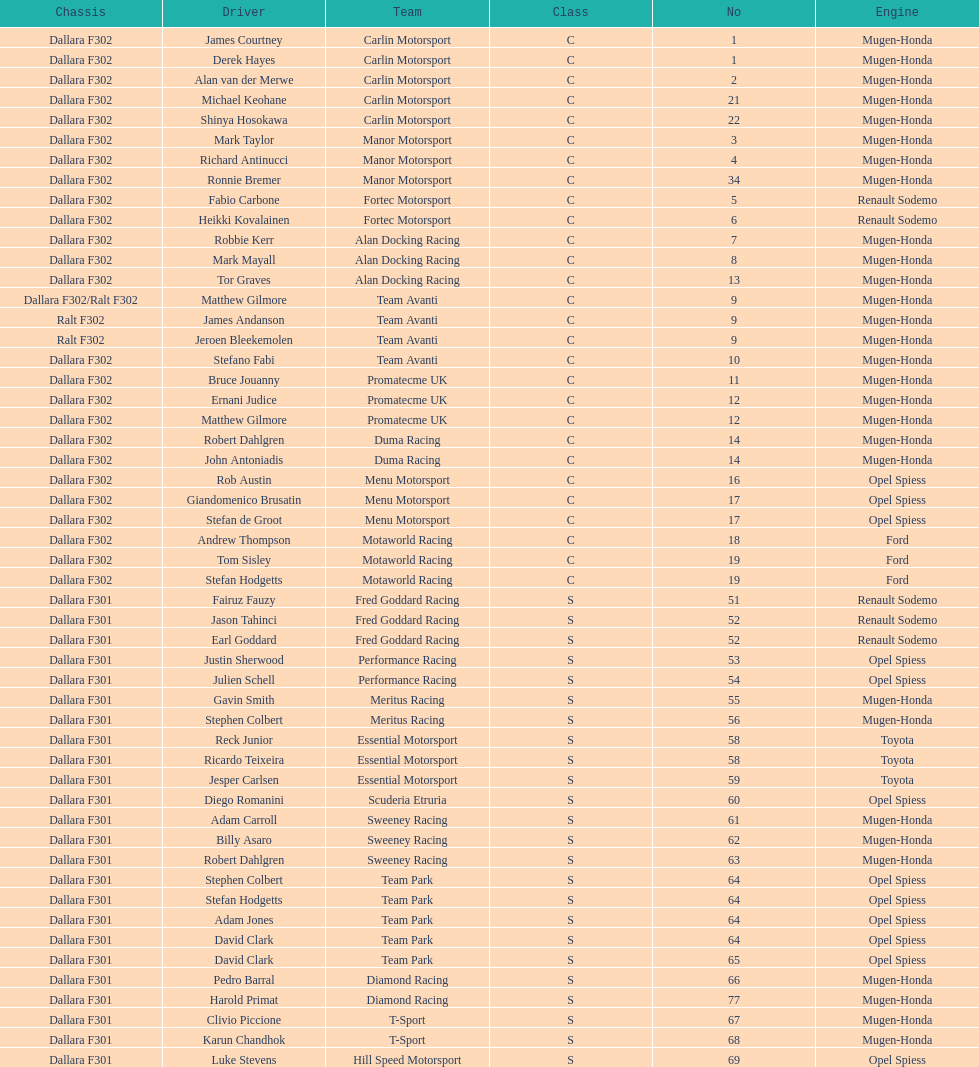What is the number of teams that had drivers all from the same country? 4. 